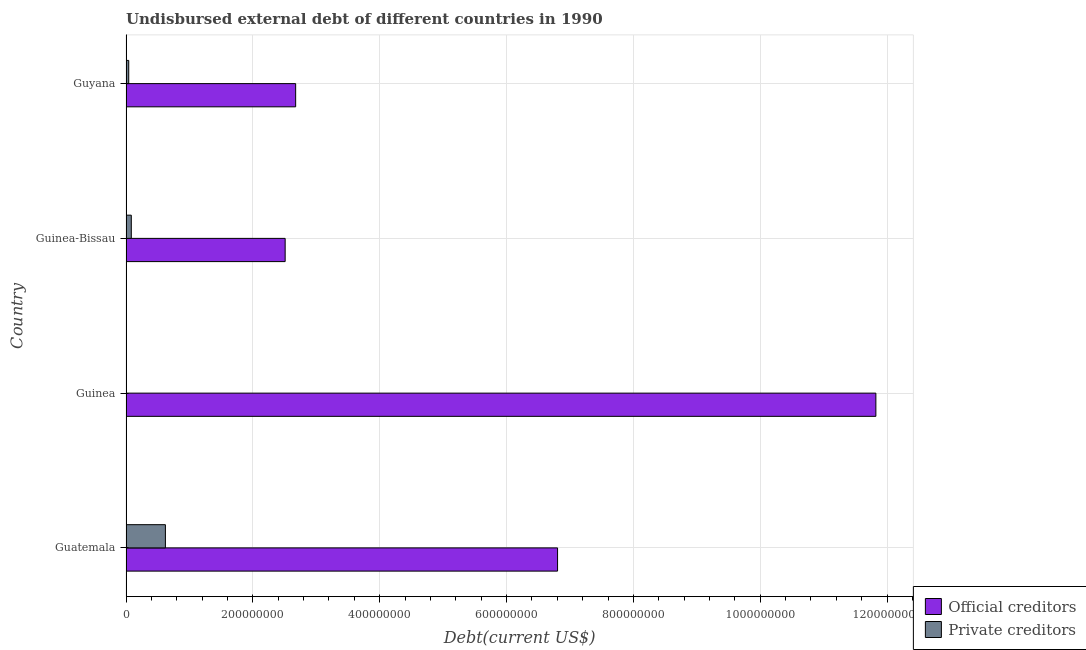How many different coloured bars are there?
Your answer should be very brief. 2. How many groups of bars are there?
Make the answer very short. 4. Are the number of bars per tick equal to the number of legend labels?
Ensure brevity in your answer.  Yes. How many bars are there on the 2nd tick from the top?
Offer a terse response. 2. What is the label of the 2nd group of bars from the top?
Your answer should be very brief. Guinea-Bissau. In how many cases, is the number of bars for a given country not equal to the number of legend labels?
Make the answer very short. 0. What is the undisbursed external debt of private creditors in Guyana?
Offer a very short reply. 4.30e+06. Across all countries, what is the maximum undisbursed external debt of private creditors?
Provide a short and direct response. 6.21e+07. Across all countries, what is the minimum undisbursed external debt of official creditors?
Provide a short and direct response. 2.51e+08. In which country was the undisbursed external debt of official creditors maximum?
Offer a terse response. Guinea. In which country was the undisbursed external debt of official creditors minimum?
Your answer should be very brief. Guinea-Bissau. What is the total undisbursed external debt of private creditors in the graph?
Provide a short and direct response. 7.50e+07. What is the difference between the undisbursed external debt of official creditors in Guatemala and that in Guyana?
Your response must be concise. 4.13e+08. What is the difference between the undisbursed external debt of private creditors in Guatemala and the undisbursed external debt of official creditors in Guinea?
Ensure brevity in your answer.  -1.12e+09. What is the average undisbursed external debt of private creditors per country?
Your answer should be compact. 1.88e+07. What is the difference between the undisbursed external debt of official creditors and undisbursed external debt of private creditors in Guyana?
Your answer should be compact. 2.63e+08. In how many countries, is the undisbursed external debt of official creditors greater than 200000000 US$?
Provide a succinct answer. 4. What is the ratio of the undisbursed external debt of official creditors in Guatemala to that in Guyana?
Give a very brief answer. 2.54. Is the undisbursed external debt of official creditors in Guatemala less than that in Guinea?
Give a very brief answer. Yes. Is the difference between the undisbursed external debt of private creditors in Guatemala and Guyana greater than the difference between the undisbursed external debt of official creditors in Guatemala and Guyana?
Provide a short and direct response. No. What is the difference between the highest and the second highest undisbursed external debt of private creditors?
Give a very brief answer. 5.38e+07. What is the difference between the highest and the lowest undisbursed external debt of official creditors?
Keep it short and to the point. 9.31e+08. In how many countries, is the undisbursed external debt of private creditors greater than the average undisbursed external debt of private creditors taken over all countries?
Offer a very short reply. 1. Is the sum of the undisbursed external debt of private creditors in Guatemala and Guinea-Bissau greater than the maximum undisbursed external debt of official creditors across all countries?
Your answer should be very brief. No. What does the 1st bar from the top in Guinea-Bissau represents?
Your response must be concise. Private creditors. What does the 1st bar from the bottom in Guinea-Bissau represents?
Give a very brief answer. Official creditors. Are all the bars in the graph horizontal?
Your answer should be very brief. Yes. How many countries are there in the graph?
Make the answer very short. 4. Does the graph contain any zero values?
Give a very brief answer. No. Does the graph contain grids?
Your response must be concise. Yes. Where does the legend appear in the graph?
Provide a short and direct response. Bottom right. How many legend labels are there?
Your answer should be very brief. 2. What is the title of the graph?
Provide a short and direct response. Undisbursed external debt of different countries in 1990. Does "Investment in Telecom" appear as one of the legend labels in the graph?
Provide a short and direct response. No. What is the label or title of the X-axis?
Your answer should be compact. Debt(current US$). What is the label or title of the Y-axis?
Offer a terse response. Country. What is the Debt(current US$) of Official creditors in Guatemala?
Offer a very short reply. 6.80e+08. What is the Debt(current US$) of Private creditors in Guatemala?
Your answer should be compact. 6.21e+07. What is the Debt(current US$) in Official creditors in Guinea?
Provide a succinct answer. 1.18e+09. What is the Debt(current US$) of Private creditors in Guinea?
Keep it short and to the point. 2.89e+05. What is the Debt(current US$) in Official creditors in Guinea-Bissau?
Your answer should be very brief. 2.51e+08. What is the Debt(current US$) of Private creditors in Guinea-Bissau?
Offer a very short reply. 8.34e+06. What is the Debt(current US$) of Official creditors in Guyana?
Provide a short and direct response. 2.67e+08. What is the Debt(current US$) in Private creditors in Guyana?
Your response must be concise. 4.30e+06. Across all countries, what is the maximum Debt(current US$) of Official creditors?
Offer a terse response. 1.18e+09. Across all countries, what is the maximum Debt(current US$) in Private creditors?
Your answer should be very brief. 6.21e+07. Across all countries, what is the minimum Debt(current US$) in Official creditors?
Ensure brevity in your answer.  2.51e+08. Across all countries, what is the minimum Debt(current US$) in Private creditors?
Provide a short and direct response. 2.89e+05. What is the total Debt(current US$) in Official creditors in the graph?
Your answer should be very brief. 2.38e+09. What is the total Debt(current US$) in Private creditors in the graph?
Your answer should be very brief. 7.50e+07. What is the difference between the Debt(current US$) of Official creditors in Guatemala and that in Guinea?
Provide a short and direct response. -5.02e+08. What is the difference between the Debt(current US$) of Private creditors in Guatemala and that in Guinea?
Your response must be concise. 6.18e+07. What is the difference between the Debt(current US$) of Official creditors in Guatemala and that in Guinea-Bissau?
Your answer should be very brief. 4.30e+08. What is the difference between the Debt(current US$) of Private creditors in Guatemala and that in Guinea-Bissau?
Your response must be concise. 5.38e+07. What is the difference between the Debt(current US$) in Official creditors in Guatemala and that in Guyana?
Give a very brief answer. 4.13e+08. What is the difference between the Debt(current US$) in Private creditors in Guatemala and that in Guyana?
Ensure brevity in your answer.  5.78e+07. What is the difference between the Debt(current US$) of Official creditors in Guinea and that in Guinea-Bissau?
Offer a very short reply. 9.31e+08. What is the difference between the Debt(current US$) in Private creditors in Guinea and that in Guinea-Bissau?
Your answer should be very brief. -8.05e+06. What is the difference between the Debt(current US$) in Official creditors in Guinea and that in Guyana?
Provide a short and direct response. 9.15e+08. What is the difference between the Debt(current US$) of Private creditors in Guinea and that in Guyana?
Your response must be concise. -4.01e+06. What is the difference between the Debt(current US$) of Official creditors in Guinea-Bissau and that in Guyana?
Offer a terse response. -1.66e+07. What is the difference between the Debt(current US$) in Private creditors in Guinea-Bissau and that in Guyana?
Offer a very short reply. 4.04e+06. What is the difference between the Debt(current US$) of Official creditors in Guatemala and the Debt(current US$) of Private creditors in Guinea?
Offer a terse response. 6.80e+08. What is the difference between the Debt(current US$) in Official creditors in Guatemala and the Debt(current US$) in Private creditors in Guinea-Bissau?
Provide a succinct answer. 6.72e+08. What is the difference between the Debt(current US$) in Official creditors in Guatemala and the Debt(current US$) in Private creditors in Guyana?
Keep it short and to the point. 6.76e+08. What is the difference between the Debt(current US$) of Official creditors in Guinea and the Debt(current US$) of Private creditors in Guinea-Bissau?
Ensure brevity in your answer.  1.17e+09. What is the difference between the Debt(current US$) of Official creditors in Guinea and the Debt(current US$) of Private creditors in Guyana?
Provide a short and direct response. 1.18e+09. What is the difference between the Debt(current US$) in Official creditors in Guinea-Bissau and the Debt(current US$) in Private creditors in Guyana?
Offer a very short reply. 2.47e+08. What is the average Debt(current US$) in Official creditors per country?
Ensure brevity in your answer.  5.95e+08. What is the average Debt(current US$) in Private creditors per country?
Provide a succinct answer. 1.88e+07. What is the difference between the Debt(current US$) of Official creditors and Debt(current US$) of Private creditors in Guatemala?
Provide a succinct answer. 6.18e+08. What is the difference between the Debt(current US$) in Official creditors and Debt(current US$) in Private creditors in Guinea?
Your answer should be very brief. 1.18e+09. What is the difference between the Debt(current US$) of Official creditors and Debt(current US$) of Private creditors in Guinea-Bissau?
Give a very brief answer. 2.43e+08. What is the difference between the Debt(current US$) in Official creditors and Debt(current US$) in Private creditors in Guyana?
Provide a short and direct response. 2.63e+08. What is the ratio of the Debt(current US$) in Official creditors in Guatemala to that in Guinea?
Offer a terse response. 0.58. What is the ratio of the Debt(current US$) in Private creditors in Guatemala to that in Guinea?
Your answer should be very brief. 214.97. What is the ratio of the Debt(current US$) of Official creditors in Guatemala to that in Guinea-Bissau?
Give a very brief answer. 2.71. What is the ratio of the Debt(current US$) of Private creditors in Guatemala to that in Guinea-Bissau?
Make the answer very short. 7.45. What is the ratio of the Debt(current US$) in Official creditors in Guatemala to that in Guyana?
Offer a very short reply. 2.54. What is the ratio of the Debt(current US$) of Private creditors in Guatemala to that in Guyana?
Offer a terse response. 14.45. What is the ratio of the Debt(current US$) of Official creditors in Guinea to that in Guinea-Bissau?
Keep it short and to the point. 4.71. What is the ratio of the Debt(current US$) of Private creditors in Guinea to that in Guinea-Bissau?
Your answer should be compact. 0.03. What is the ratio of the Debt(current US$) in Official creditors in Guinea to that in Guyana?
Your answer should be compact. 4.42. What is the ratio of the Debt(current US$) of Private creditors in Guinea to that in Guyana?
Provide a short and direct response. 0.07. What is the ratio of the Debt(current US$) in Official creditors in Guinea-Bissau to that in Guyana?
Provide a short and direct response. 0.94. What is the ratio of the Debt(current US$) in Private creditors in Guinea-Bissau to that in Guyana?
Offer a very short reply. 1.94. What is the difference between the highest and the second highest Debt(current US$) in Official creditors?
Your answer should be very brief. 5.02e+08. What is the difference between the highest and the second highest Debt(current US$) of Private creditors?
Your answer should be compact. 5.38e+07. What is the difference between the highest and the lowest Debt(current US$) of Official creditors?
Offer a very short reply. 9.31e+08. What is the difference between the highest and the lowest Debt(current US$) in Private creditors?
Keep it short and to the point. 6.18e+07. 